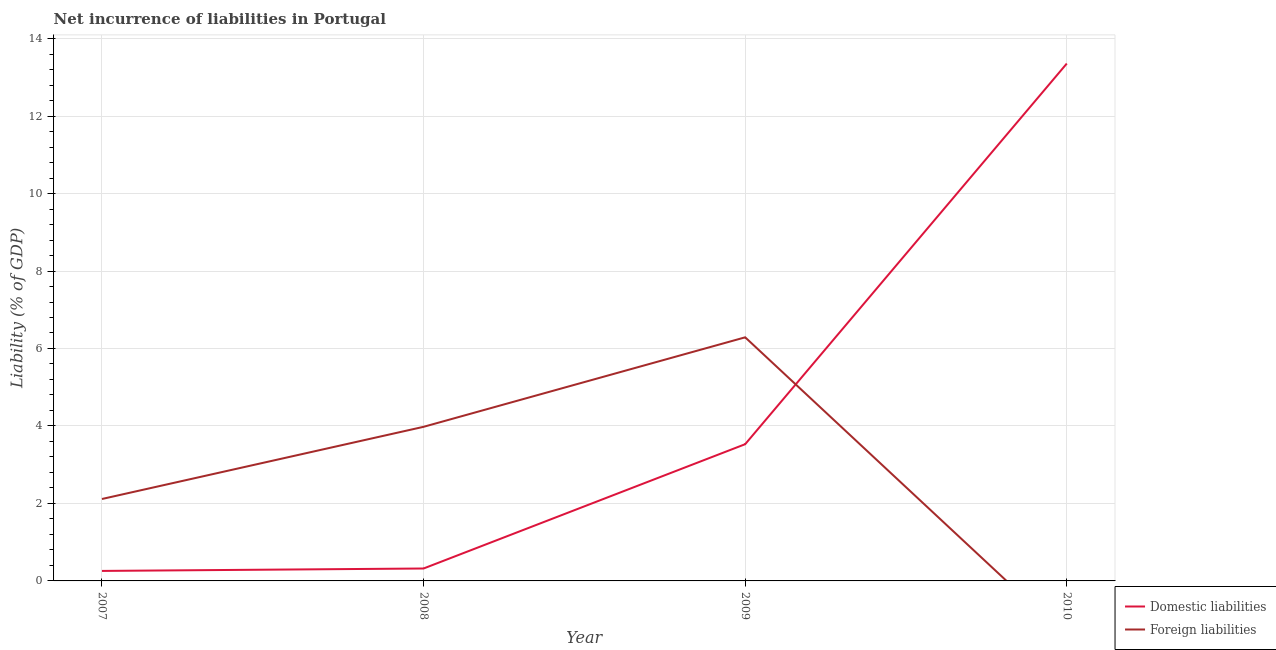What is the incurrence of domestic liabilities in 2009?
Ensure brevity in your answer.  3.53. Across all years, what is the maximum incurrence of foreign liabilities?
Give a very brief answer. 6.29. In which year was the incurrence of foreign liabilities maximum?
Give a very brief answer. 2009. What is the total incurrence of foreign liabilities in the graph?
Provide a succinct answer. 12.38. What is the difference between the incurrence of domestic liabilities in 2007 and that in 2009?
Provide a short and direct response. -3.27. What is the difference between the incurrence of foreign liabilities in 2009 and the incurrence of domestic liabilities in 2007?
Provide a succinct answer. 6.03. What is the average incurrence of foreign liabilities per year?
Ensure brevity in your answer.  3.1. In the year 2009, what is the difference between the incurrence of foreign liabilities and incurrence of domestic liabilities?
Provide a succinct answer. 2.76. In how many years, is the incurrence of domestic liabilities greater than 8.8 %?
Keep it short and to the point. 1. What is the ratio of the incurrence of domestic liabilities in 2008 to that in 2010?
Ensure brevity in your answer.  0.02. Is the difference between the incurrence of foreign liabilities in 2008 and 2009 greater than the difference between the incurrence of domestic liabilities in 2008 and 2009?
Ensure brevity in your answer.  Yes. What is the difference between the highest and the second highest incurrence of domestic liabilities?
Offer a terse response. 9.83. What is the difference between the highest and the lowest incurrence of foreign liabilities?
Offer a terse response. 6.29. In how many years, is the incurrence of domestic liabilities greater than the average incurrence of domestic liabilities taken over all years?
Keep it short and to the point. 1. How many years are there in the graph?
Ensure brevity in your answer.  4. Are the values on the major ticks of Y-axis written in scientific E-notation?
Your answer should be compact. No. Does the graph contain any zero values?
Your answer should be compact. Yes. Does the graph contain grids?
Provide a succinct answer. Yes. What is the title of the graph?
Your answer should be compact. Net incurrence of liabilities in Portugal. What is the label or title of the Y-axis?
Provide a short and direct response. Liability (% of GDP). What is the Liability (% of GDP) in Domestic liabilities in 2007?
Ensure brevity in your answer.  0.26. What is the Liability (% of GDP) of Foreign liabilities in 2007?
Give a very brief answer. 2.11. What is the Liability (% of GDP) in Domestic liabilities in 2008?
Give a very brief answer. 0.32. What is the Liability (% of GDP) in Foreign liabilities in 2008?
Your answer should be very brief. 3.98. What is the Liability (% of GDP) in Domestic liabilities in 2009?
Give a very brief answer. 3.53. What is the Liability (% of GDP) of Foreign liabilities in 2009?
Your answer should be very brief. 6.29. What is the Liability (% of GDP) of Domestic liabilities in 2010?
Offer a terse response. 13.36. What is the Liability (% of GDP) in Foreign liabilities in 2010?
Ensure brevity in your answer.  0. Across all years, what is the maximum Liability (% of GDP) of Domestic liabilities?
Your answer should be compact. 13.36. Across all years, what is the maximum Liability (% of GDP) of Foreign liabilities?
Offer a very short reply. 6.29. Across all years, what is the minimum Liability (% of GDP) of Domestic liabilities?
Keep it short and to the point. 0.26. Across all years, what is the minimum Liability (% of GDP) in Foreign liabilities?
Your answer should be very brief. 0. What is the total Liability (% of GDP) of Domestic liabilities in the graph?
Your response must be concise. 17.46. What is the total Liability (% of GDP) in Foreign liabilities in the graph?
Give a very brief answer. 12.38. What is the difference between the Liability (% of GDP) of Domestic liabilities in 2007 and that in 2008?
Your answer should be very brief. -0.06. What is the difference between the Liability (% of GDP) in Foreign liabilities in 2007 and that in 2008?
Make the answer very short. -1.86. What is the difference between the Liability (% of GDP) of Domestic liabilities in 2007 and that in 2009?
Keep it short and to the point. -3.27. What is the difference between the Liability (% of GDP) of Foreign liabilities in 2007 and that in 2009?
Your response must be concise. -4.17. What is the difference between the Liability (% of GDP) of Domestic liabilities in 2007 and that in 2010?
Provide a short and direct response. -13.1. What is the difference between the Liability (% of GDP) in Domestic liabilities in 2008 and that in 2009?
Your answer should be compact. -3.21. What is the difference between the Liability (% of GDP) of Foreign liabilities in 2008 and that in 2009?
Offer a terse response. -2.31. What is the difference between the Liability (% of GDP) of Domestic liabilities in 2008 and that in 2010?
Give a very brief answer. -13.03. What is the difference between the Liability (% of GDP) of Domestic liabilities in 2009 and that in 2010?
Provide a short and direct response. -9.83. What is the difference between the Liability (% of GDP) of Domestic liabilities in 2007 and the Liability (% of GDP) of Foreign liabilities in 2008?
Provide a succinct answer. -3.72. What is the difference between the Liability (% of GDP) in Domestic liabilities in 2007 and the Liability (% of GDP) in Foreign liabilities in 2009?
Make the answer very short. -6.03. What is the difference between the Liability (% of GDP) of Domestic liabilities in 2008 and the Liability (% of GDP) of Foreign liabilities in 2009?
Keep it short and to the point. -5.97. What is the average Liability (% of GDP) in Domestic liabilities per year?
Provide a succinct answer. 4.37. What is the average Liability (% of GDP) of Foreign liabilities per year?
Make the answer very short. 3.1. In the year 2007, what is the difference between the Liability (% of GDP) in Domestic liabilities and Liability (% of GDP) in Foreign liabilities?
Give a very brief answer. -1.86. In the year 2008, what is the difference between the Liability (% of GDP) of Domestic liabilities and Liability (% of GDP) of Foreign liabilities?
Your answer should be compact. -3.66. In the year 2009, what is the difference between the Liability (% of GDP) of Domestic liabilities and Liability (% of GDP) of Foreign liabilities?
Offer a terse response. -2.76. What is the ratio of the Liability (% of GDP) of Domestic liabilities in 2007 to that in 2008?
Ensure brevity in your answer.  0.81. What is the ratio of the Liability (% of GDP) of Foreign liabilities in 2007 to that in 2008?
Keep it short and to the point. 0.53. What is the ratio of the Liability (% of GDP) of Domestic liabilities in 2007 to that in 2009?
Your answer should be compact. 0.07. What is the ratio of the Liability (% of GDP) of Foreign liabilities in 2007 to that in 2009?
Offer a very short reply. 0.34. What is the ratio of the Liability (% of GDP) in Domestic liabilities in 2007 to that in 2010?
Ensure brevity in your answer.  0.02. What is the ratio of the Liability (% of GDP) of Domestic liabilities in 2008 to that in 2009?
Make the answer very short. 0.09. What is the ratio of the Liability (% of GDP) of Foreign liabilities in 2008 to that in 2009?
Provide a short and direct response. 0.63. What is the ratio of the Liability (% of GDP) in Domestic liabilities in 2008 to that in 2010?
Make the answer very short. 0.02. What is the ratio of the Liability (% of GDP) of Domestic liabilities in 2009 to that in 2010?
Your response must be concise. 0.26. What is the difference between the highest and the second highest Liability (% of GDP) in Domestic liabilities?
Offer a very short reply. 9.83. What is the difference between the highest and the second highest Liability (% of GDP) in Foreign liabilities?
Provide a short and direct response. 2.31. What is the difference between the highest and the lowest Liability (% of GDP) in Domestic liabilities?
Make the answer very short. 13.1. What is the difference between the highest and the lowest Liability (% of GDP) of Foreign liabilities?
Your answer should be compact. 6.29. 